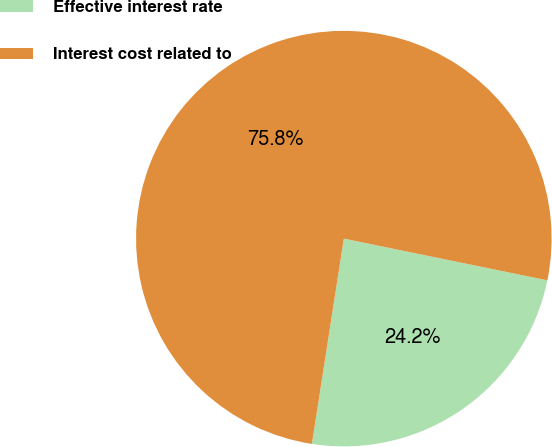Convert chart. <chart><loc_0><loc_0><loc_500><loc_500><pie_chart><fcel>Effective interest rate<fcel>Interest cost related to<nl><fcel>24.24%<fcel>75.76%<nl></chart> 